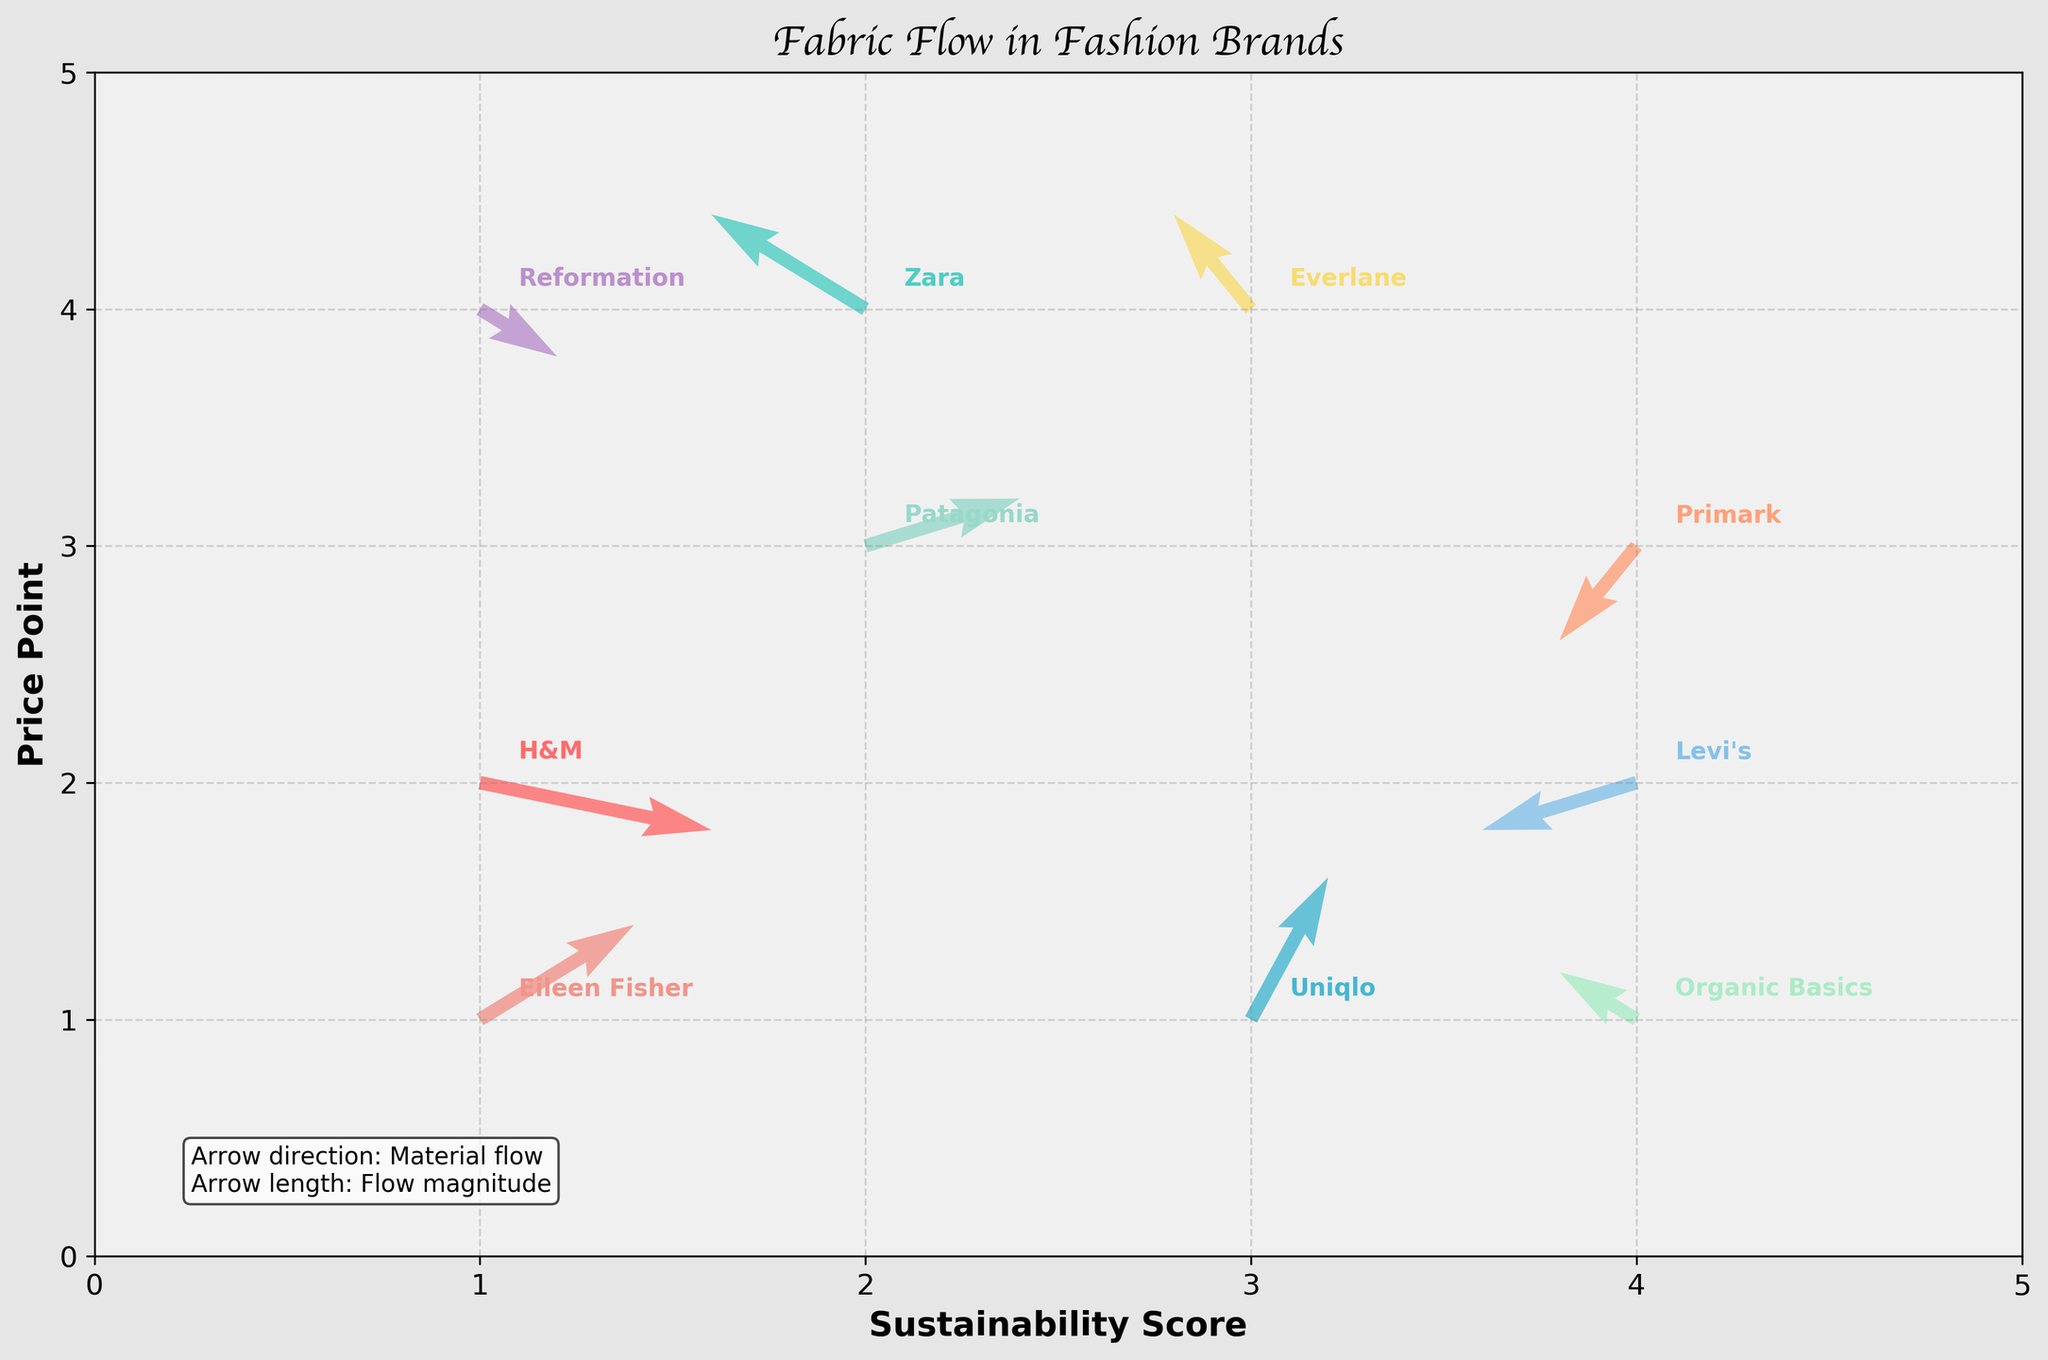What is the title of the plot? The title is located at the top of the plot, which generally describes the main theme or purpose of the visualization.
Answer: Fabric Flow in Fashion Brands Which brands have arrows pointing downward? Arrows pointing downward indicate a negative flow (in the y-direction). By looking at the plot, identify the arrows that point downward.
Answer: H&M, Reformation At which point does the brand Eileen Fisher start? Eileen Fisher's starting point is marked by the (x, y) coordinates on the plot.
Answer: (1, 1) What is the magnitude and direction of Patagonia's material flow? The plot shows arrows with direction (u, v). The magnitude can be determined by calculating the length of the vector sqrt(u^2 + v^2). For Patagonia, the vector is (2, 1), so the magnitude is calculated.
Answer: Direction: (2, 1), Magnitude: √5 Which brands have a positive x-component in their material flow? A positive x-component means the 'u' value is positive. Identify these from the plot.
Answer: H&M, Uniqlo, Patagonia, Reformation, Eileen Fisher Which brand has the highest y-value at its starting point? The y-value of starting points is directly visible by identifying each brand's starting coordinates on the plot.
Answer: Reformation How does the direction of material flow for Levi's compare to Organic Basics? Compare the (u, v) vectors for Levi's and Organic Basics to see the direction of their arrows on the plot.
Answer: Levi's: (-2, -1), Organic Basics: (-1, 1) Which brands have their material flow components entirely negative? Completely negative components mean both 'u' and 'v' values are negative. Check each vector.
Answer: Primark Which brand has the shortest material flow magnitude? The shortest vector is determined by comparing the magnitudes √(u^2 + v^2) for each brand. Calculate these values.
Answer: H&M How many brands have arrows starting with an x-value of 4? Count the number of arrows starting at x = 4 by checking each brand's starting point coordinates.
Answer: 3 